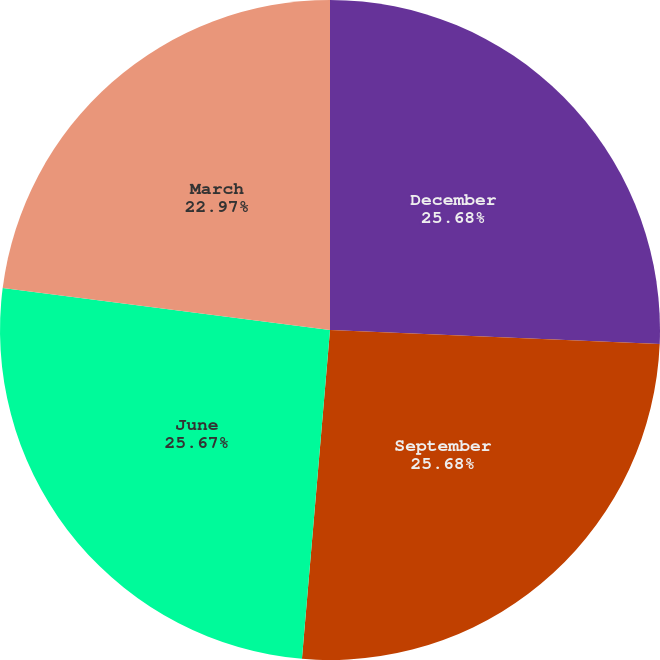Convert chart to OTSL. <chart><loc_0><loc_0><loc_500><loc_500><pie_chart><fcel>December<fcel>September<fcel>June<fcel>March<nl><fcel>25.68%<fcel>25.68%<fcel>25.68%<fcel>22.97%<nl></chart> 